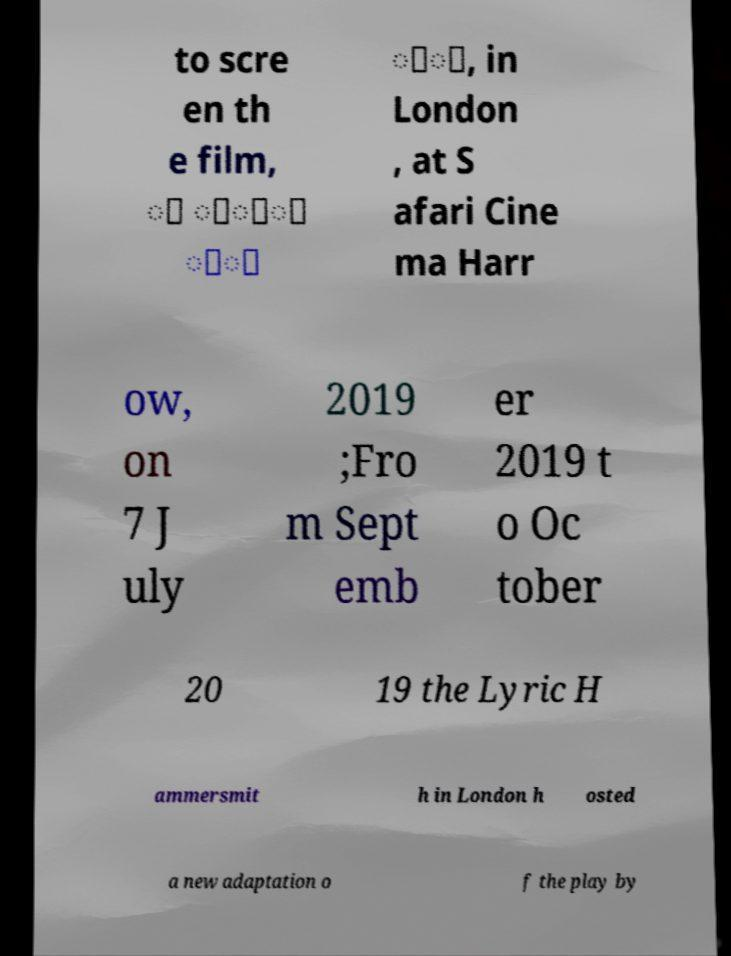Can you read and provide the text displayed in the image?This photo seems to have some interesting text. Can you extract and type it out for me? to scre en th e film, ு ொ்ை ி் ீு, in London , at S afari Cine ma Harr ow, on 7 J uly 2019 ;Fro m Sept emb er 2019 t o Oc tober 20 19 the Lyric H ammersmit h in London h osted a new adaptation o f the play by 